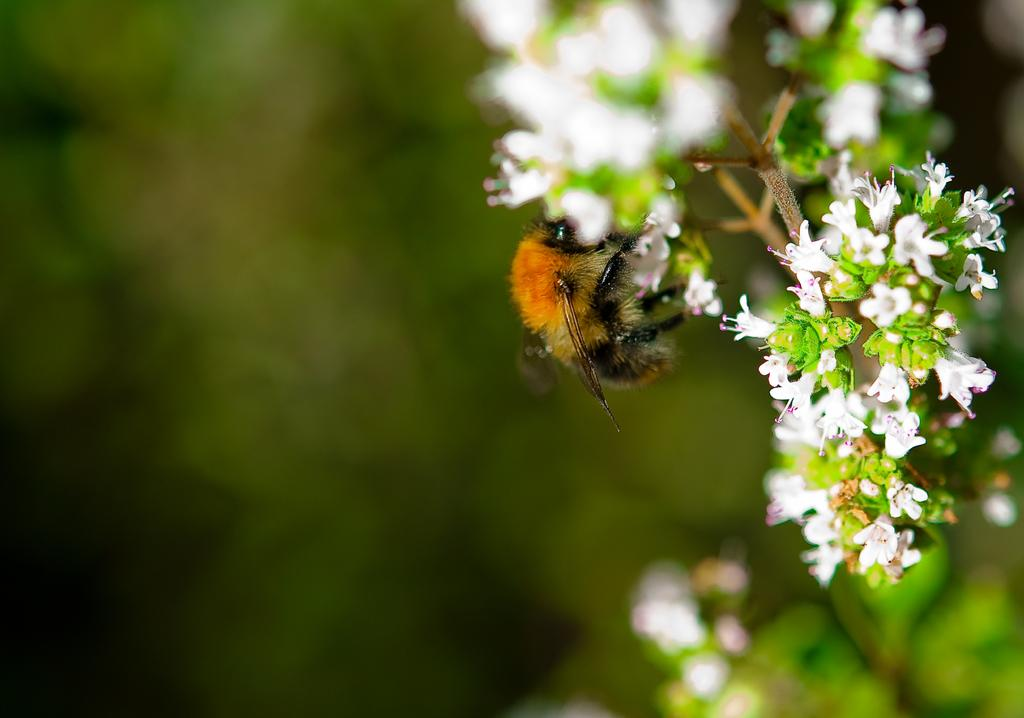What type of living organism can be seen in the image? There is an insect in the image. What is the insect sitting on or near? There is a stem in the image. What other natural elements are present in the image? There are flowers in the image. How would you describe the background of the image? The background of the image is blurred. What type of boat can be seen in the image? There is no boat present in the image. How does the insect say good-bye to the flowers in the image? Insects do not have the ability to say good-bye, and there is no indication of any interaction between the insect and the flowers in the image. 